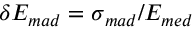<formula> <loc_0><loc_0><loc_500><loc_500>E _ { m a d } = _ { m a d } / E _ { m e d }</formula> 